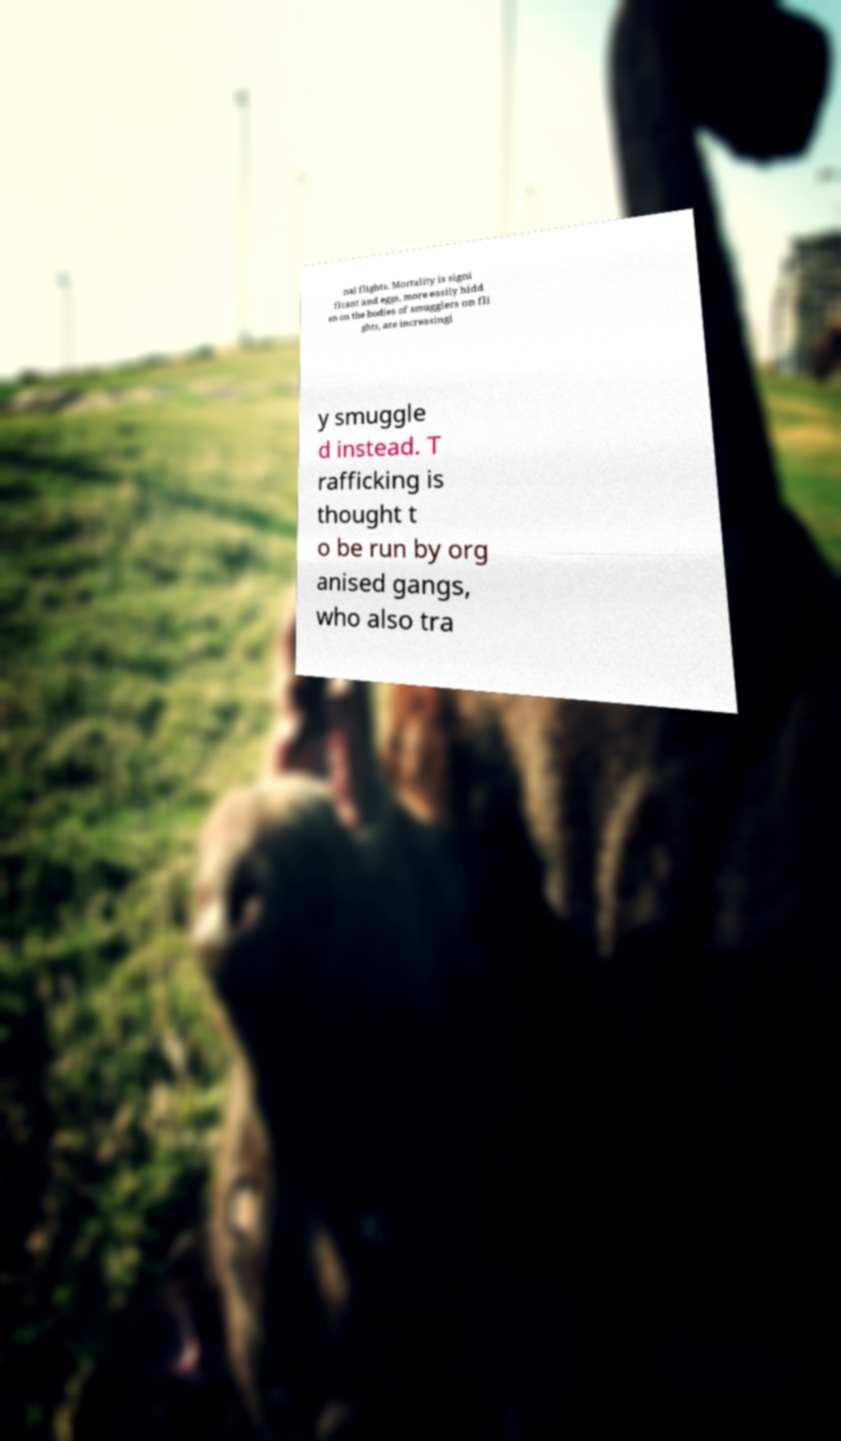Can you read and provide the text displayed in the image?This photo seems to have some interesting text. Can you extract and type it out for me? nal flights. Mortality is signi ficant and eggs, more easily hidd en on the bodies of smugglers on fli ghts, are increasingl y smuggle d instead. T rafficking is thought t o be run by org anised gangs, who also tra 